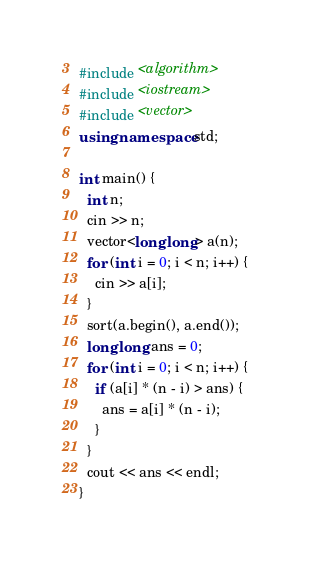Convert code to text. <code><loc_0><loc_0><loc_500><loc_500><_C++_>#include <algorithm>
#include <iostream>
#include <vector>
using namespace std;

int main() {
  int n;
  cin >> n;
  vector<long long> a(n);
  for (int i = 0; i < n; i++) {
    cin >> a[i];
  }
  sort(a.begin(), a.end());
  long long ans = 0;
  for (int i = 0; i < n; i++) {
    if (a[i] * (n - i) > ans) {
      ans = a[i] * (n - i);
    }
  }
  cout << ans << endl;
}
</code> 